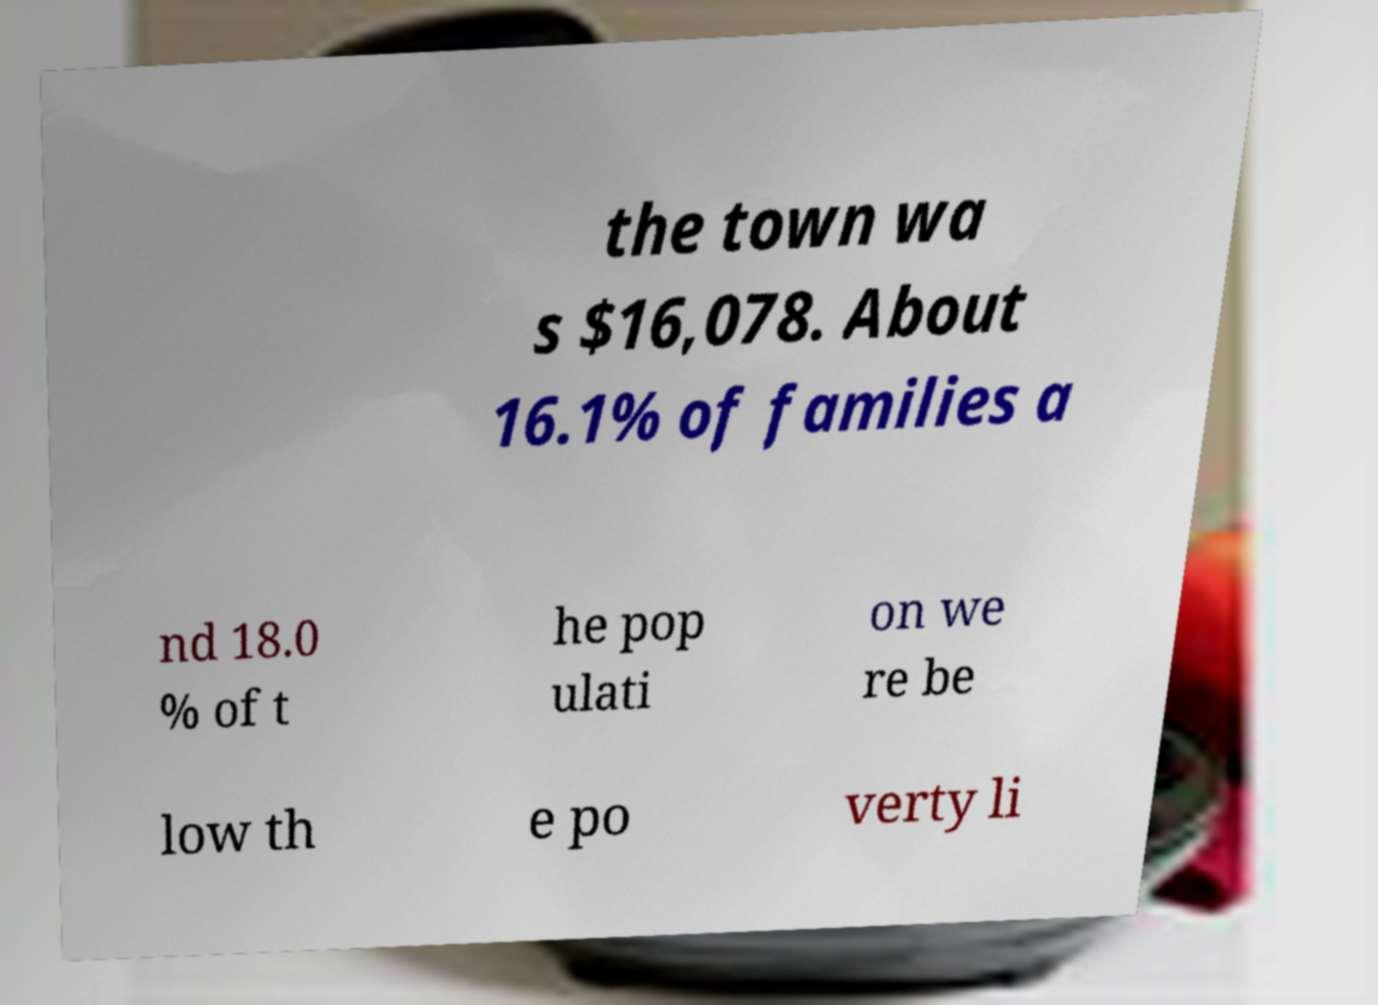Please identify and transcribe the text found in this image. the town wa s $16,078. About 16.1% of families a nd 18.0 % of t he pop ulati on we re be low th e po verty li 